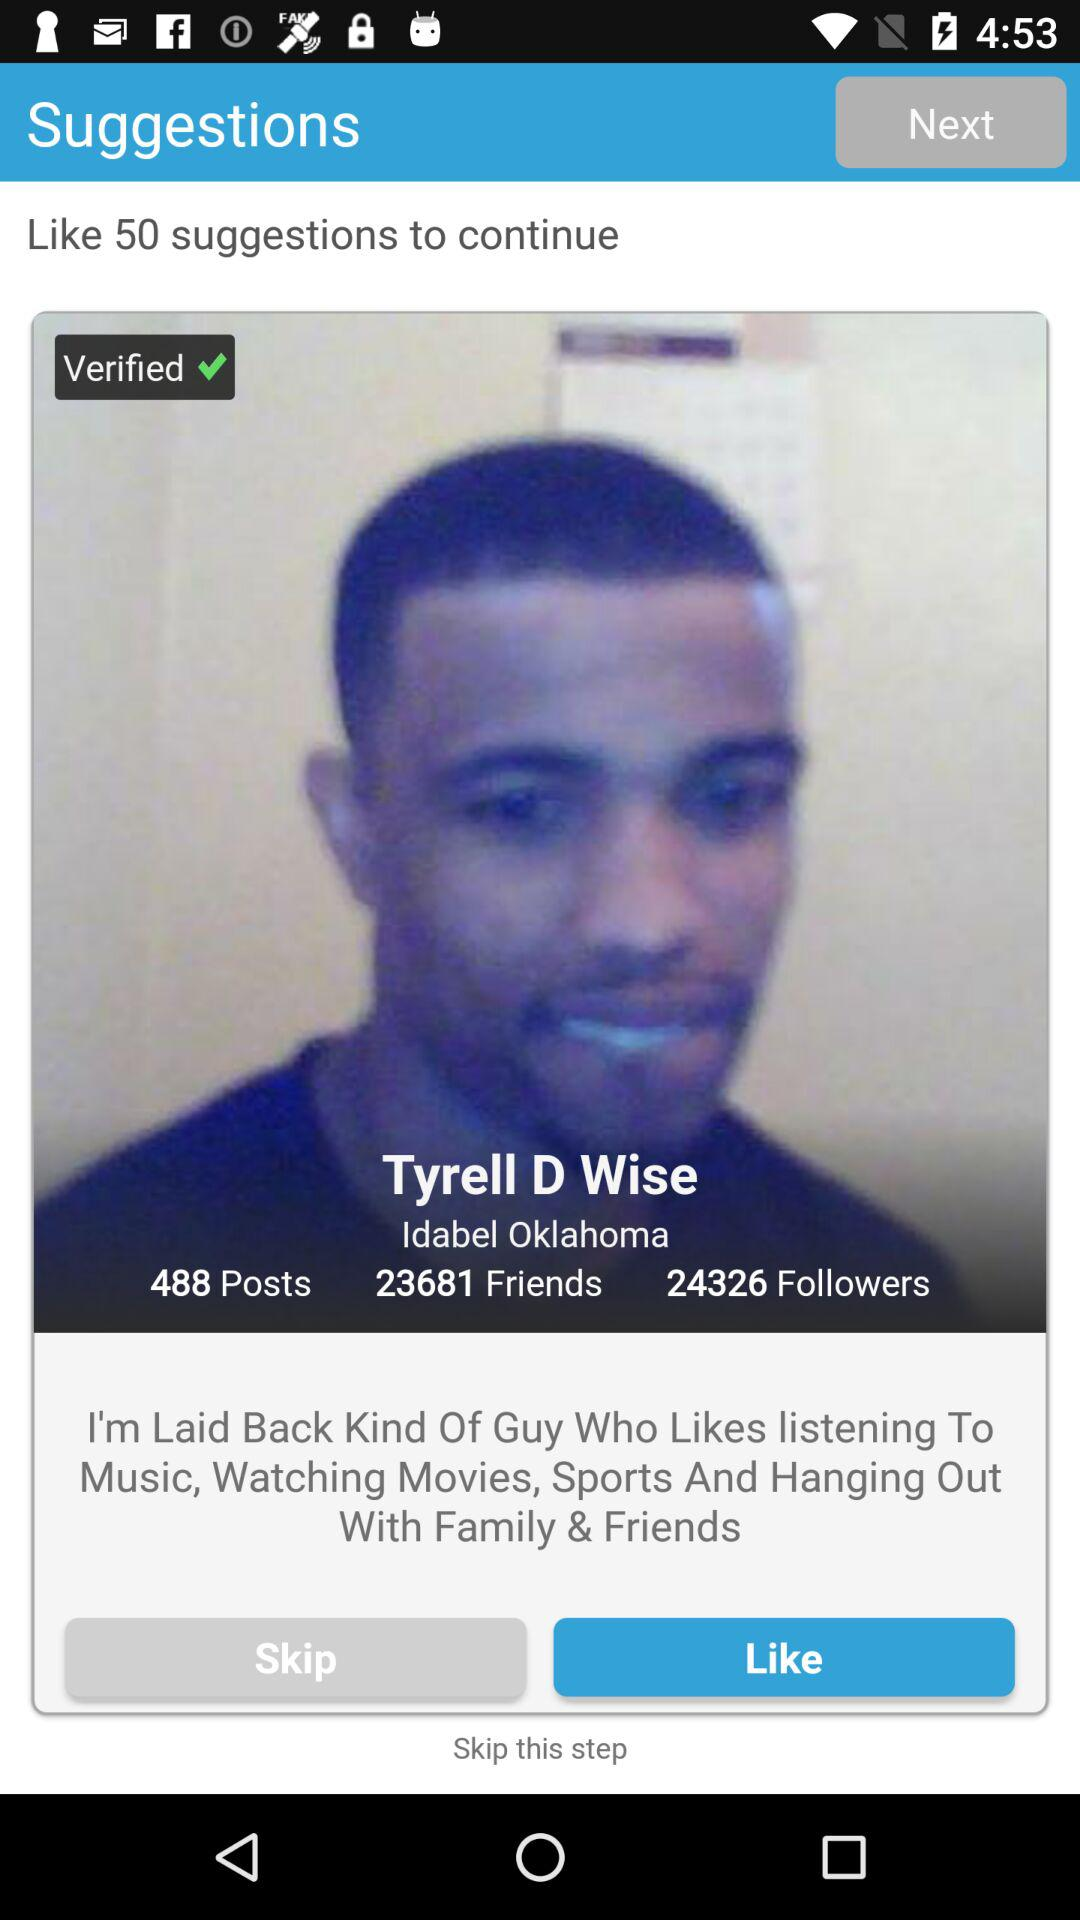How many followers does the user have?
Answer the question using a single word or phrase. 24326 